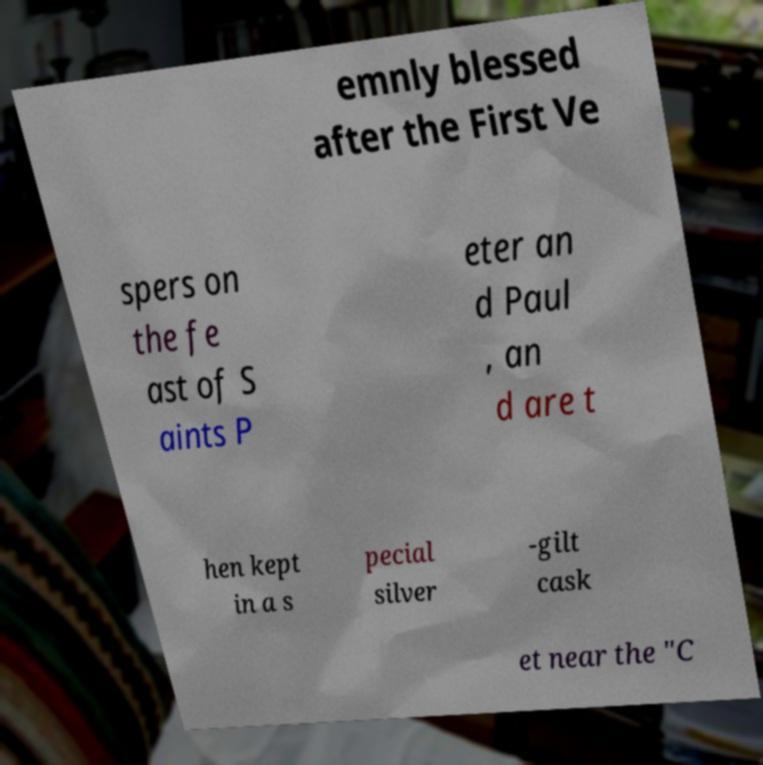Can you accurately transcribe the text from the provided image for me? emnly blessed after the First Ve spers on the fe ast of S aints P eter an d Paul , an d are t hen kept in a s pecial silver -gilt cask et near the "C 